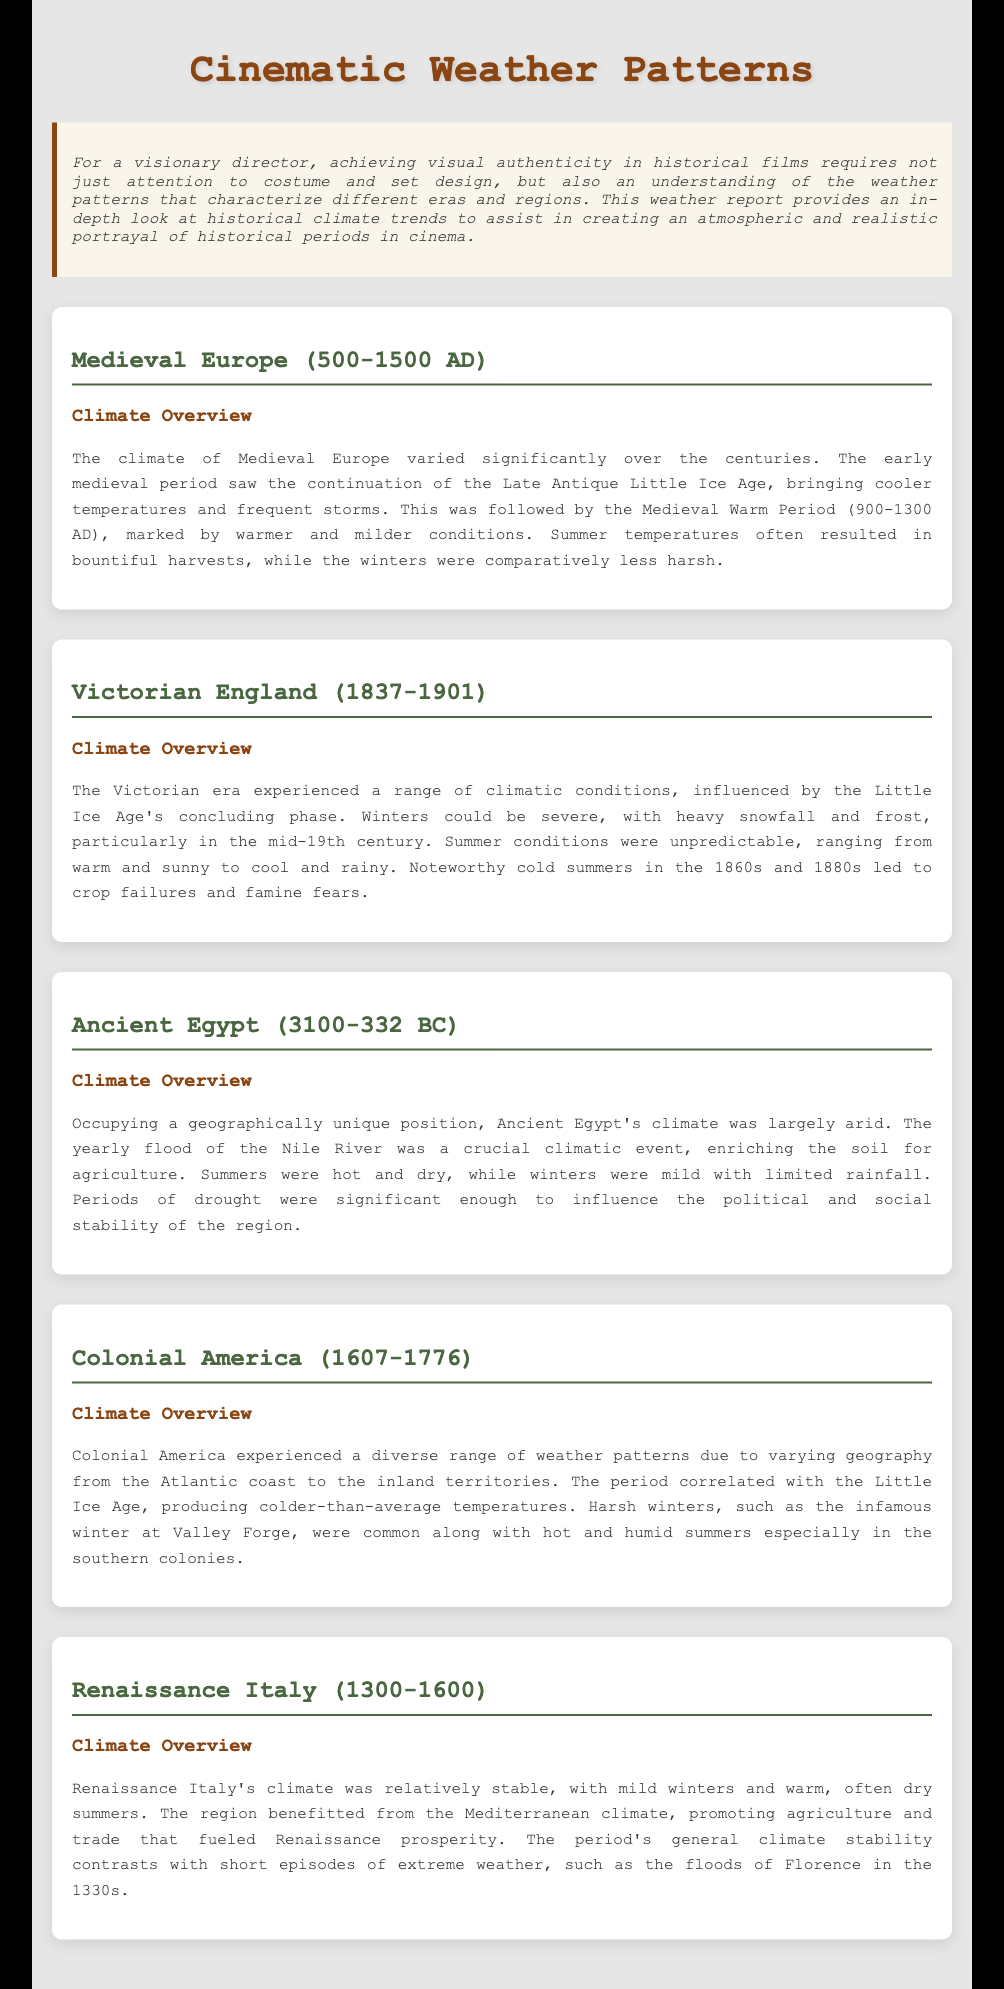What period is known as the Medieval Warm Period? The Medieval Warm Period occurred from 900 to 1300 AD in Medieval Europe.
Answer: 900-1300 AD During which era did severe winters occur in Victorian England? Severe winters were particularly noted in the mid-19th century in Victorian England.
Answer: Mid-19th century What significant climatic event enriched the soil in Ancient Egypt? The yearly flood of the Nile River was crucial for agriculture in Ancient Egypt.
Answer: Nile River flood What was the primary climate characteristic of Colonial America? Colonial America experienced colder-than-average temperatures due to the Little Ice Age.
Answer: Little Ice Age What type of climate did Renaissance Italy benefit from? Renaissance Italy benefitted from a Mediterranean climate, promoting agriculture.
Answer: Mediterranean climate Which region experienced hot and dry summers along with mild winters? Ancient Egypt had hot and dry summers with mild winters and limited rainfall.
Answer: Ancient Egypt What historical climate trend is highlighted in both Colonial America and Medieval Europe? Both periods correlated with the Little Ice Age, leading to colder temperatures.
Answer: Little Ice Age What are the two main weather characteristics of the climate in Medieval Europe? The climate showed cooler temperatures and frequent storms in the early period.
Answer: Cooler temperatures and frequent storms 